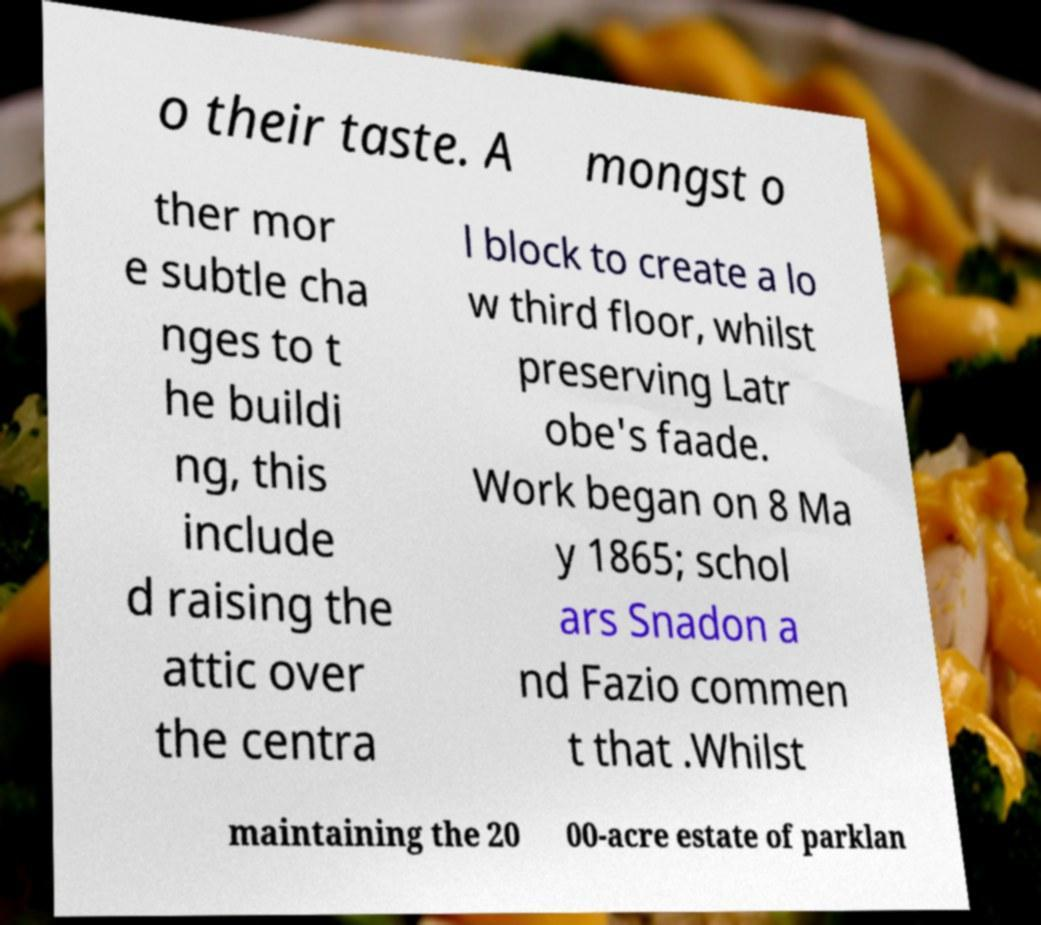There's text embedded in this image that I need extracted. Can you transcribe it verbatim? o their taste. A mongst o ther mor e subtle cha nges to t he buildi ng, this include d raising the attic over the centra l block to create a lo w third floor, whilst preserving Latr obe's faade. Work began on 8 Ma y 1865; schol ars Snadon a nd Fazio commen t that .Whilst maintaining the 20 00-acre estate of parklan 